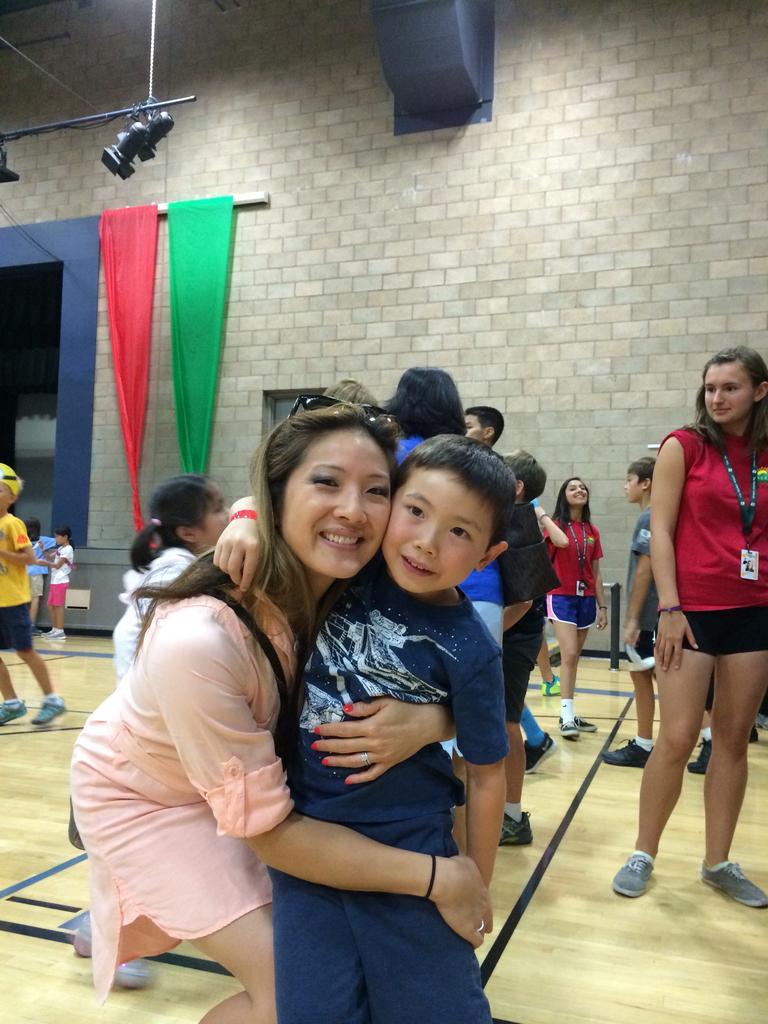Please provide a concise description of this image. The boy in the blue T-shirt is standing beside the woman who is wearing a pink dress. Both of them are smiling. Behind them, we see many people standing. On the right side, the girl in red T-shirt who is wearing the Id card is standing. She is smiling. Behind them, we see a wall. We even see curtains which are in red and green color. This picture might be clicked in the indoor stadium. 